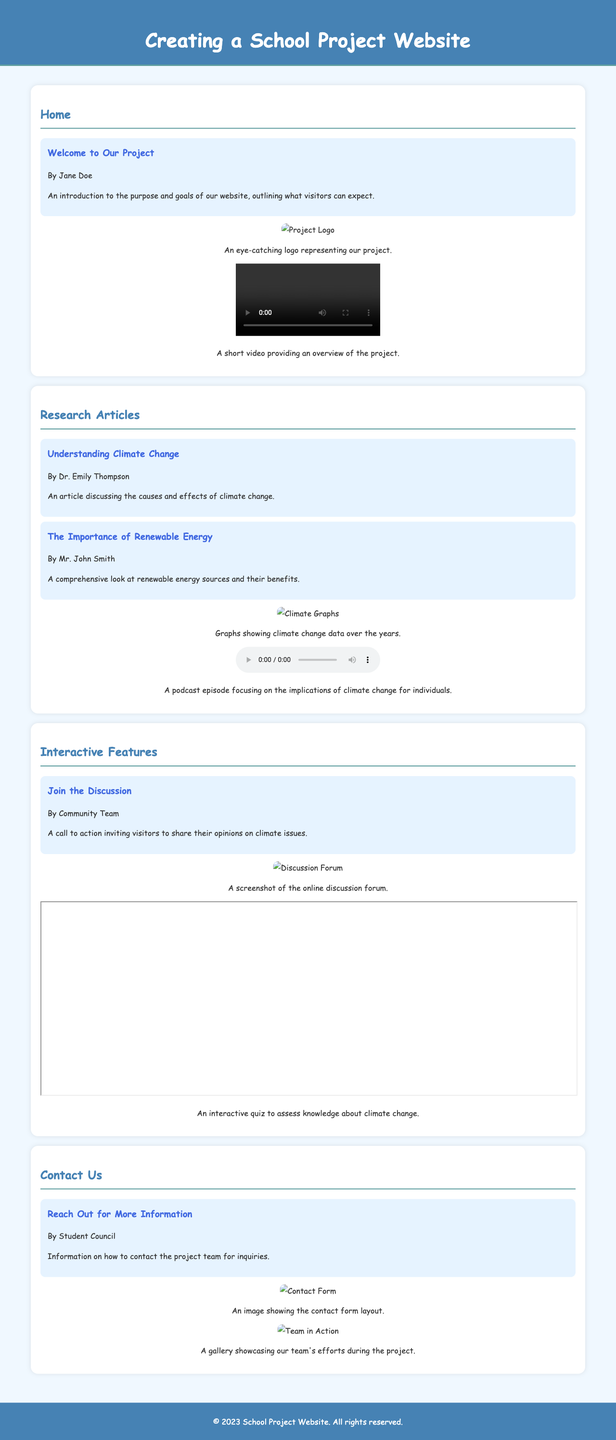what is the title of the website? The title of the website is indicated in the document's head section and displayed at the top of the webpage.
Answer: Creating a School Project Website who wrote the "Understanding Climate Change" article? The author of the article is mentioned just below the title in the document.
Answer: Dr. Emily Thompson what multimedia element accompanies the "Welcome to Our Project" article? The multimedia element includes an image and a video found within the Home section.
Answer: An image and a video how many articles are listed under the "Research Articles" section? The number of articles can be counted from the subheadings in the Research Articles section.
Answer: Two which section contains interactive features? This section is explicitly titled and covers interactive features for user engagement.
Answer: Interactive Features what type of multimedia item is used for "Join the Discussion"? The specific multimedia item linked to this call to action is identified in the Interactive Features section.
Answer: An image and an iframe what is the purpose of the "Contact Us" section? The purpose of this section is described in the introductory text found in the respective section.
Answer: To provide contact information how many images are included in the "Contact Us" section? The total number can be calculated by counting the multimedia items labeled in that specific section.
Answer: Two 